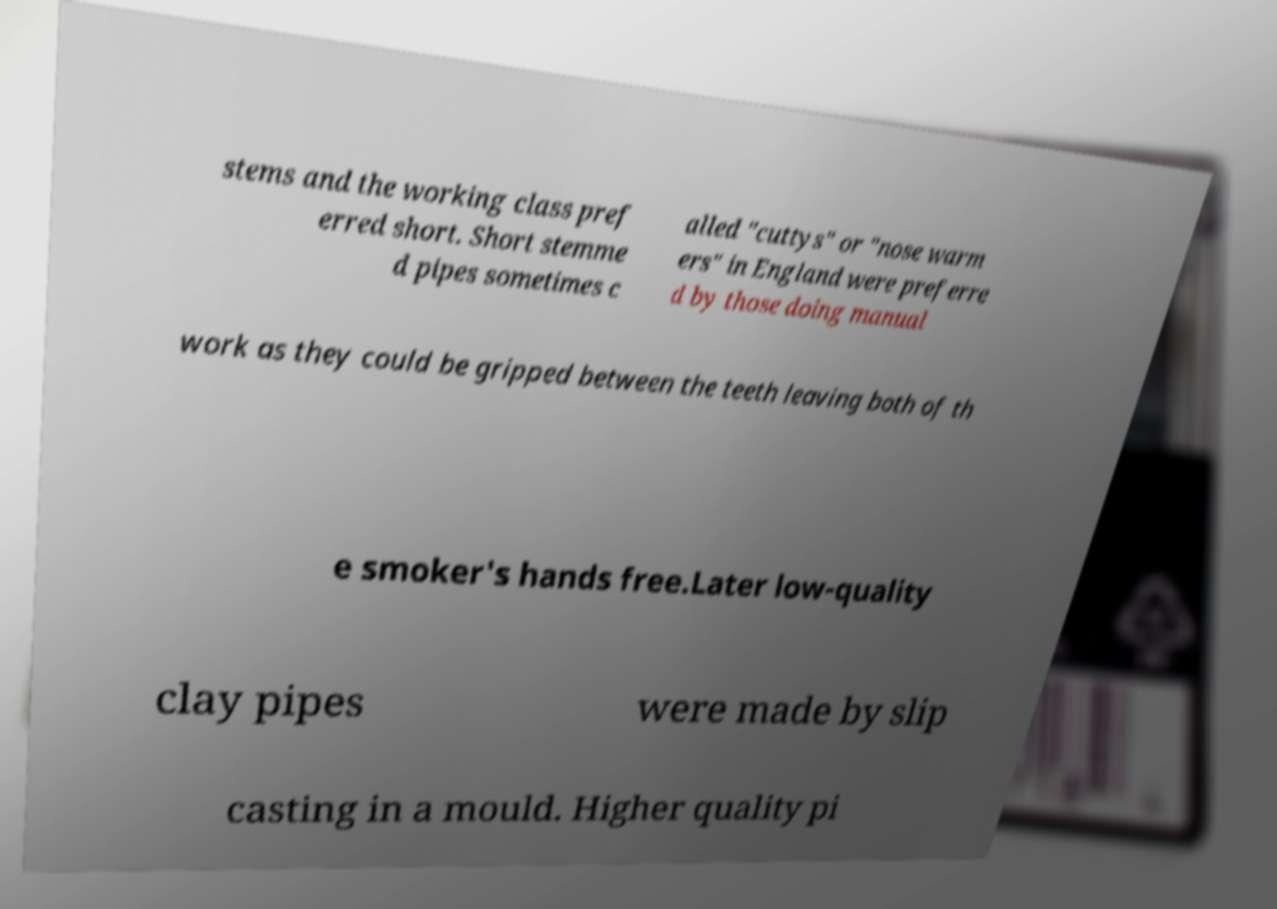Could you assist in decoding the text presented in this image and type it out clearly? stems and the working class pref erred short. Short stemme d pipes sometimes c alled "cuttys" or "nose warm ers" in England were preferre d by those doing manual work as they could be gripped between the teeth leaving both of th e smoker's hands free.Later low-quality clay pipes were made by slip casting in a mould. Higher quality pi 